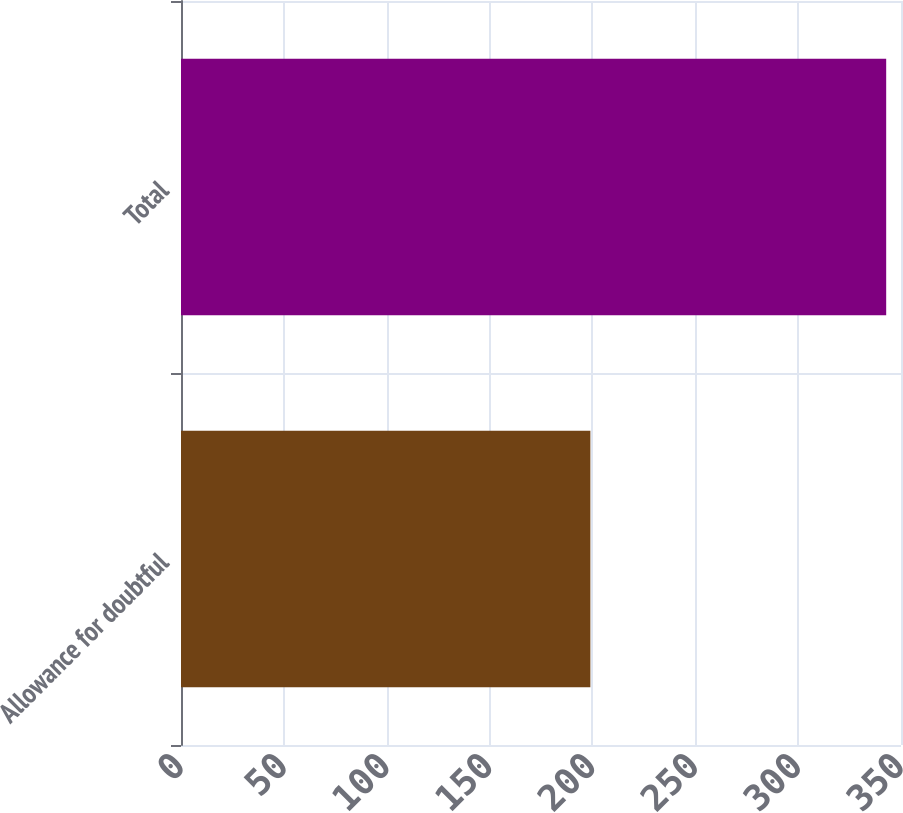Convert chart. <chart><loc_0><loc_0><loc_500><loc_500><bar_chart><fcel>Allowance for doubtful<fcel>Total<nl><fcel>199<fcel>342.8<nl></chart> 